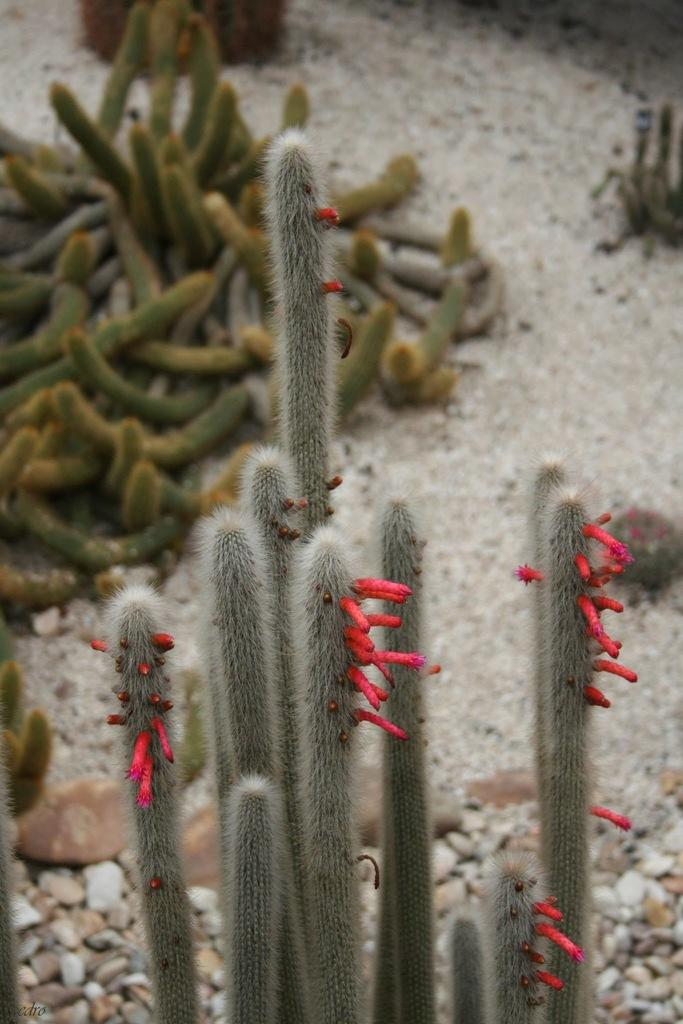What type of living organisms can be seen in the image? Plants can be seen in the image. What other objects are present in the image besides plants? There are stones in the image. What type of holiday is being celebrated in the image? There is no indication of a holiday being celebrated in the image, as it only features plants and stones. What type of yoke is being used to carry the plants in the image? There is no yoke present in the image, as it only features plants and stones. 